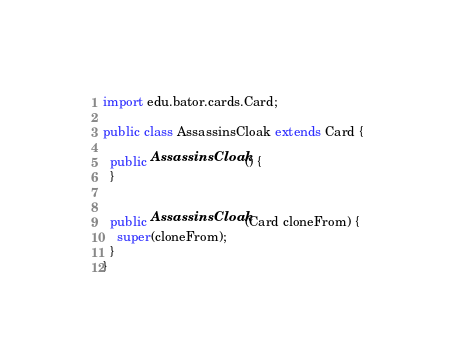Convert code to text. <code><loc_0><loc_0><loc_500><loc_500><_Java_>import edu.bator.cards.Card;

public class AssassinsCloak extends Card {

  public AssassinsCloak() {
  }


  public AssassinsCloak(Card cloneFrom) {
    super(cloneFrom);
  }
}
</code> 